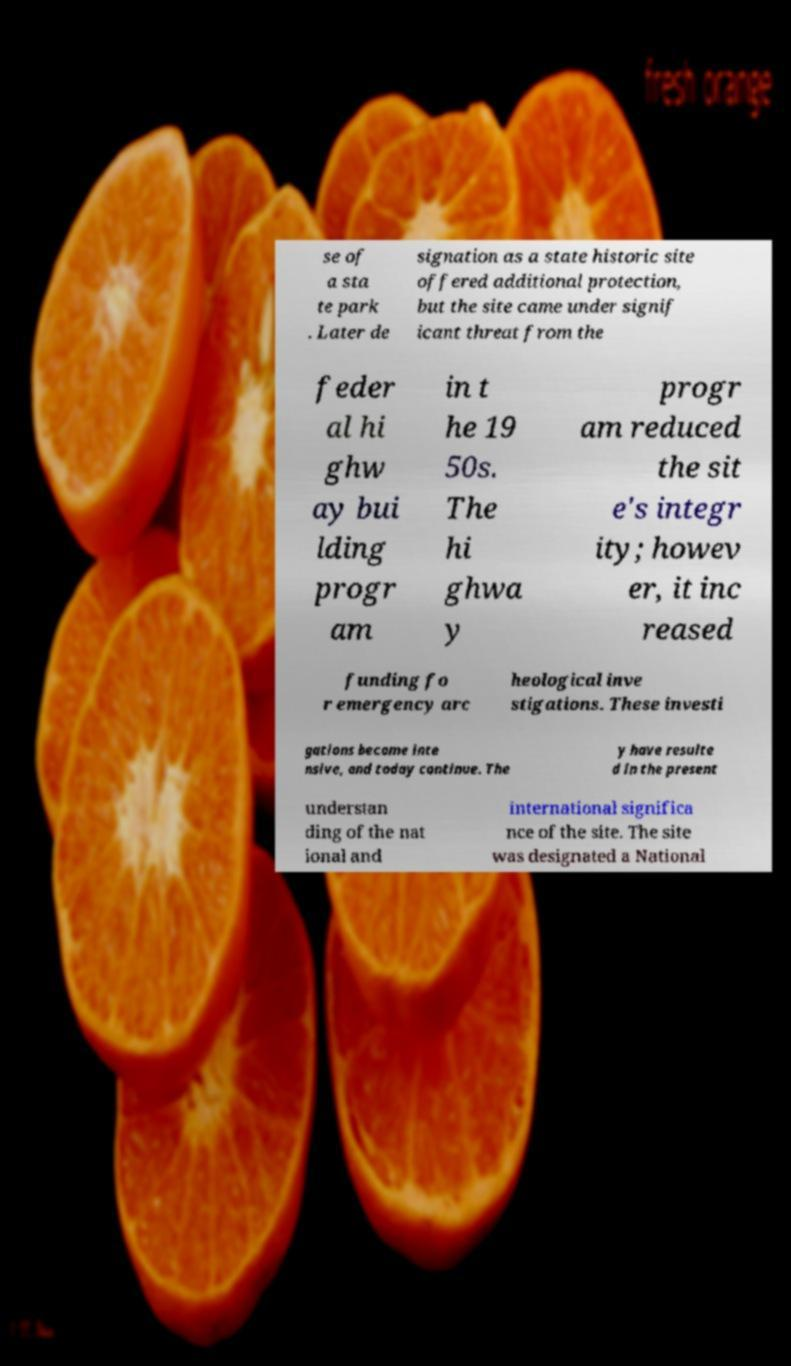Please read and relay the text visible in this image. What does it say? se of a sta te park . Later de signation as a state historic site offered additional protection, but the site came under signif icant threat from the feder al hi ghw ay bui lding progr am in t he 19 50s. The hi ghwa y progr am reduced the sit e's integr ity; howev er, it inc reased funding fo r emergency arc heological inve stigations. These investi gations became inte nsive, and today continue. The y have resulte d in the present understan ding of the nat ional and international significa nce of the site. The site was designated a National 